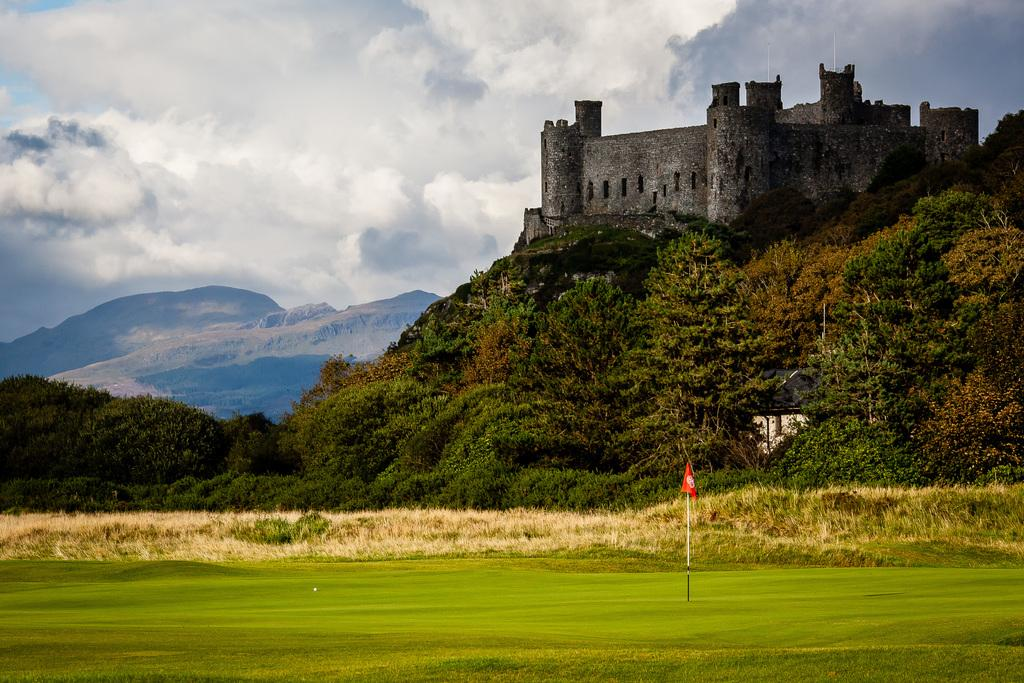What type of structure is in the image? There is a castle in the image. What type of vegetation can be seen in the image? There are trees in the image. What is the terrain like in the image? There is a hill in the image, and there are hills visible in the background. What is the weather like in the image? The sky is visible in the background, and clouds are present, suggesting a partly cloudy day. What is the ground like in the image? There is grass and ground visible in the image. How many jars of jelly are visible on the castle walls in the image? There are no jars of jelly visible on the castle walls in the image. What type of cars can be seen driving on the hill in the image? There are no cars visible in the image; it features a castle, trees, hills, and a sky with clouds. 